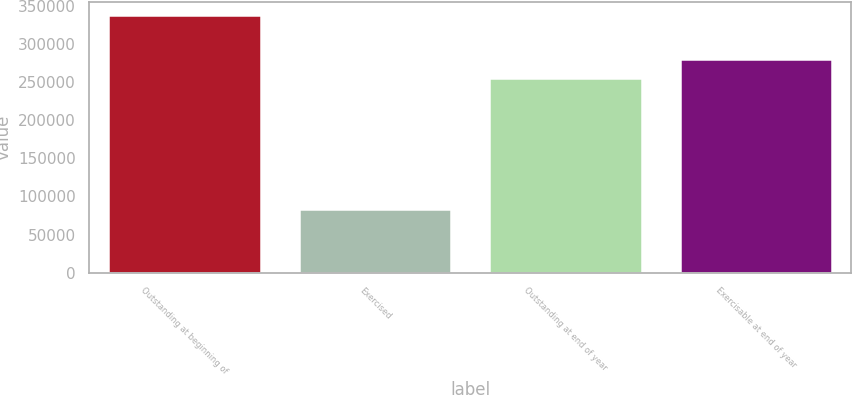<chart> <loc_0><loc_0><loc_500><loc_500><bar_chart><fcel>Outstanding at beginning of<fcel>Exercised<fcel>Outstanding at end of year<fcel>Exercisable at end of year<nl><fcel>338680<fcel>83335<fcel>255345<fcel>280880<nl></chart> 